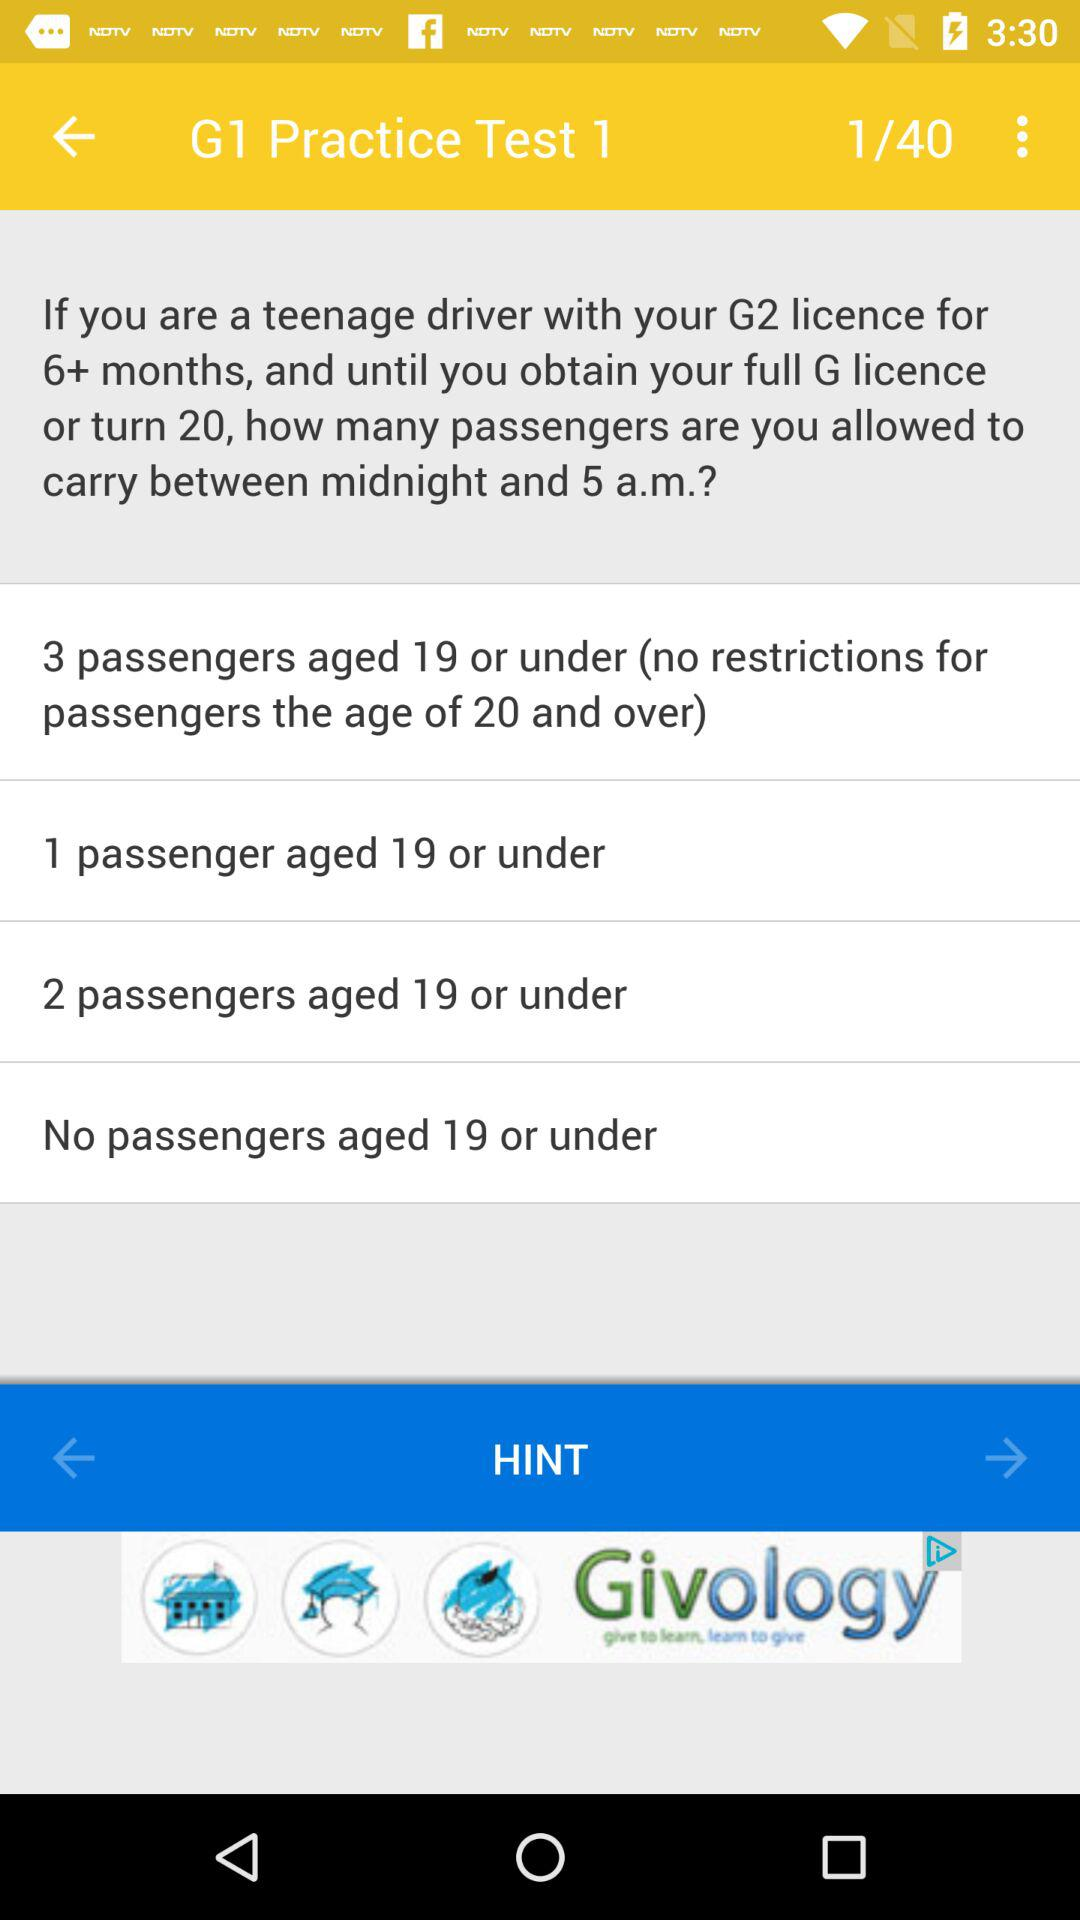What is the total number of pages in the "G1 Practice Test 1"? There are a total of 40 pages in the "G1 Practice Test 1". 